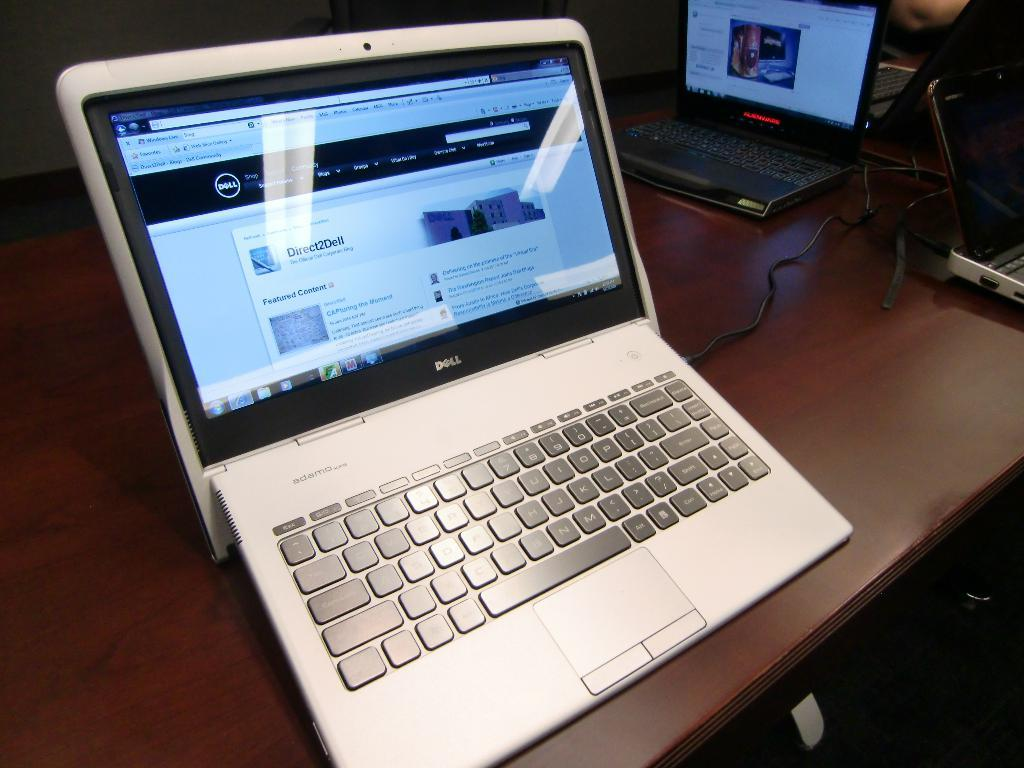What is the main subject of the image? The main subject of the image is a system. Where is the system located in the image? The system is on a table in the image. Can you see a nest in the image? There is no nest present in the image. Does the system in the image express any feelings of hate? The image is a still image and does not depict emotions or feelings, so it cannot express hate. 